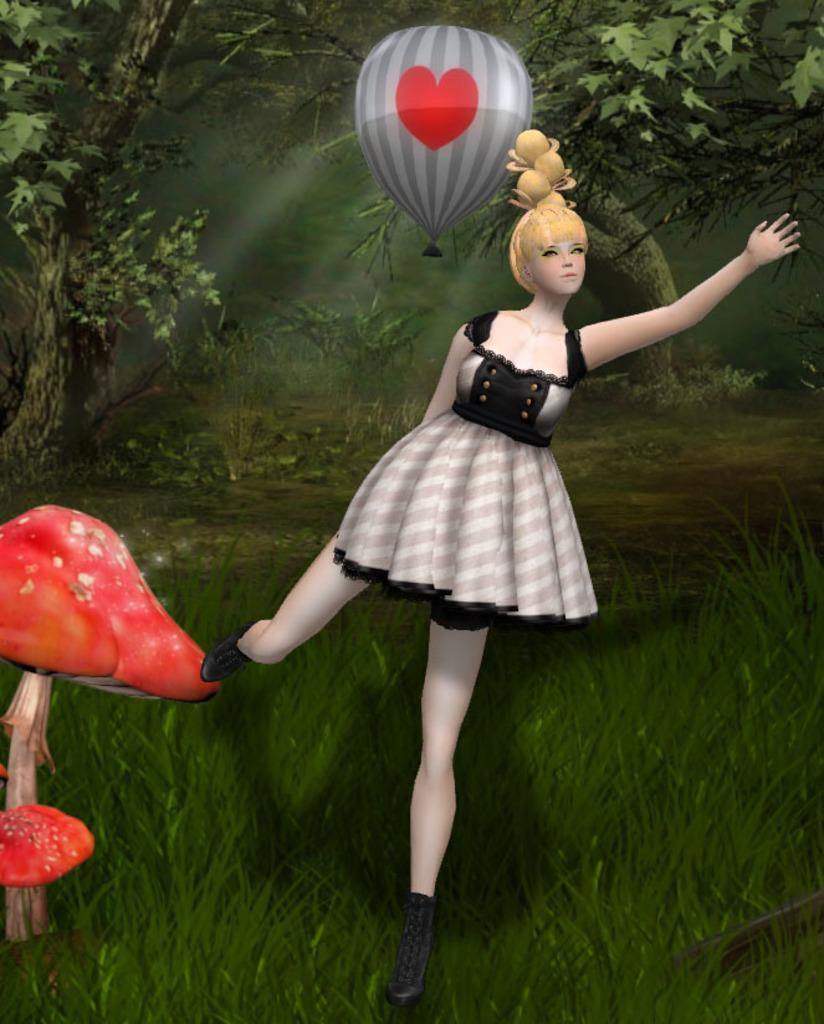What type of doll is in the image? There is a woman doll in the image. What is the woman doll wearing? The woman doll is wearing a white and black dress. What other object can be seen in the image? There is a balloon in the image. What type of natural elements are present in the image? There are trees in the image. What other object can be found in the image? There is a red color mushroom in the image. What is the nature of the image? The image is an animated picture. How many cars are parked near the trees in the image? There are no cars present in the image; it features a woman doll, a balloon, trees, and a red mushroom in an animated setting. 